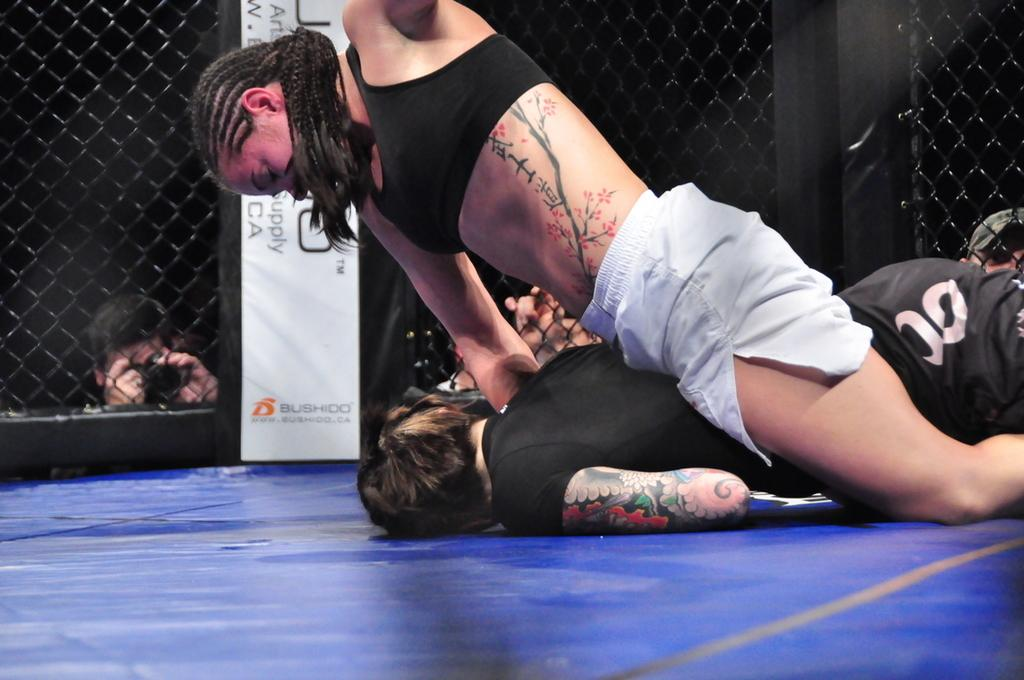What is the woman doing in the image? The woman is sitting on a person in the image. What color is the surface they are sitting on? The surface they are on is blue. What can be seen beside them in the image? There is a fence beside them in the image. What is happening outside the fence in the image? There are other persons outside the fence in the image. What type of beam is holding up the roof in the image? There is no roof or beam present in the image; it features a woman sitting on a person with a fence and other persons outside the fence. 